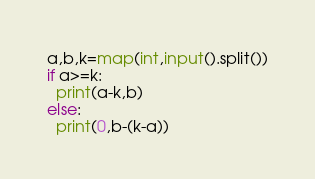Convert code to text. <code><loc_0><loc_0><loc_500><loc_500><_Python_>a,b,k=map(int,input().split())
if a>=k:
  print(a-k,b)
else:
  print(0,b-(k-a))</code> 